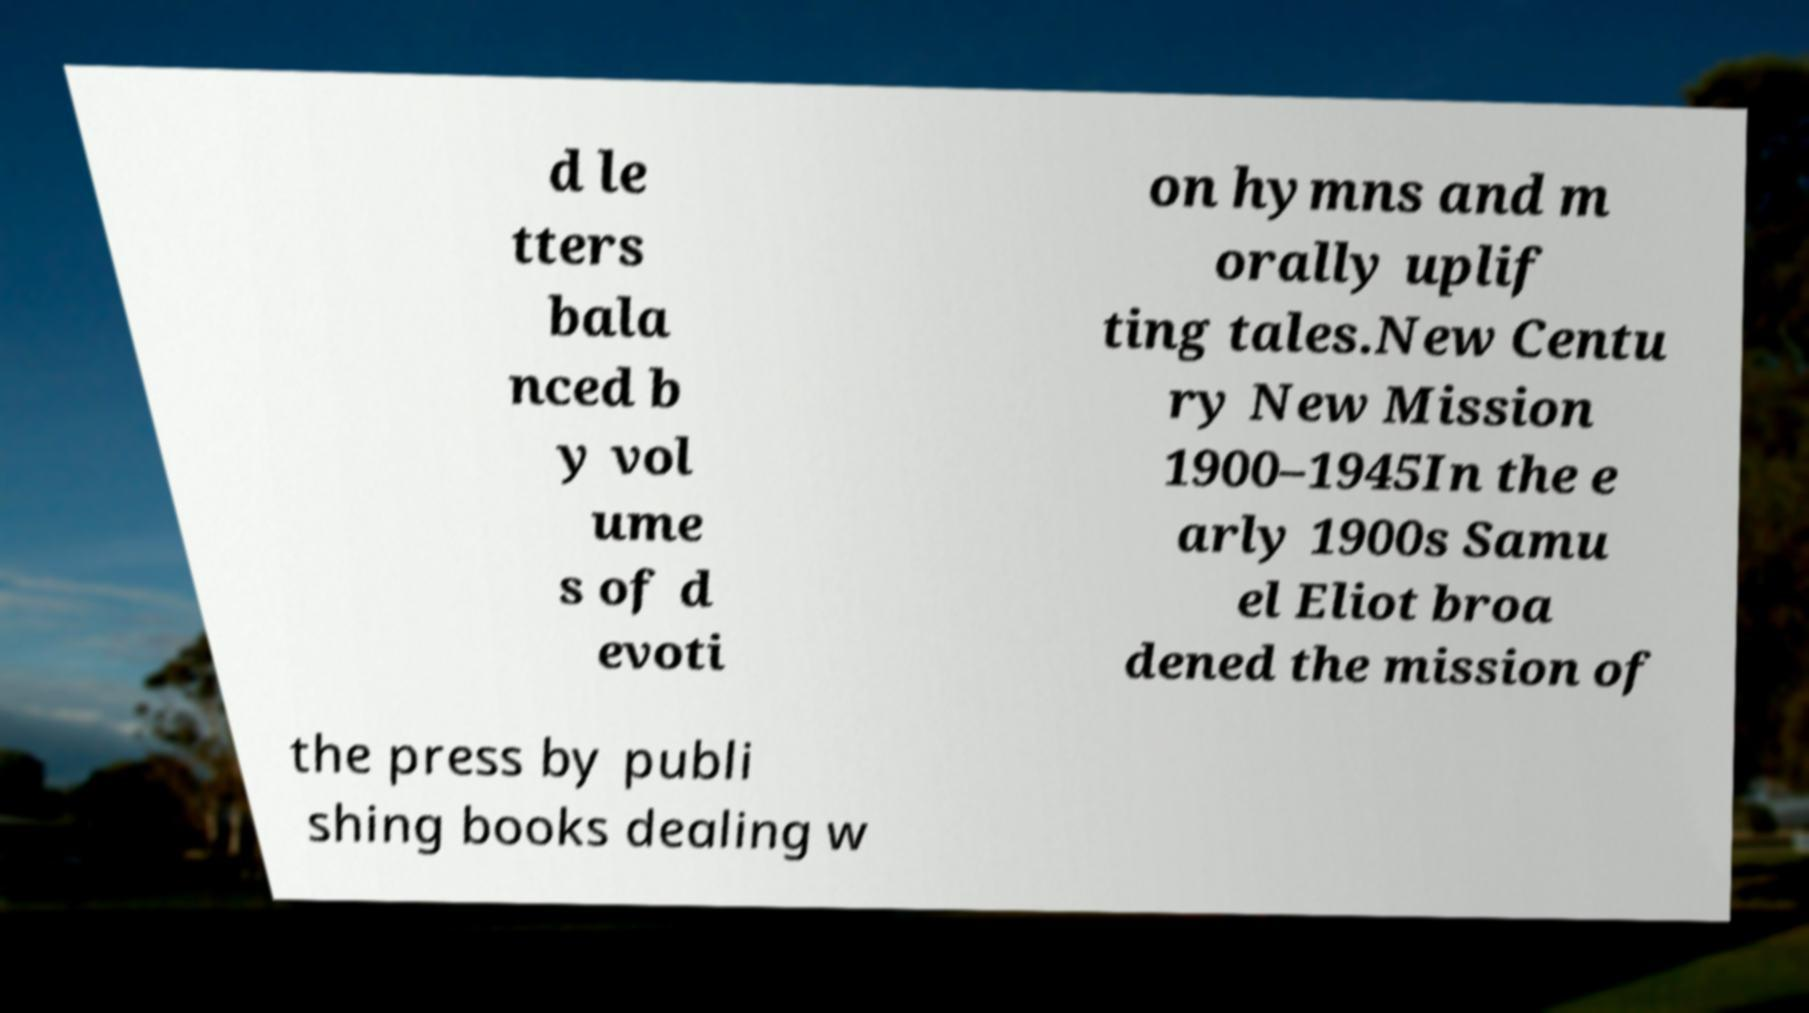Could you extract and type out the text from this image? d le tters bala nced b y vol ume s of d evoti on hymns and m orally uplif ting tales.New Centu ry New Mission 1900–1945In the e arly 1900s Samu el Eliot broa dened the mission of the press by publi shing books dealing w 